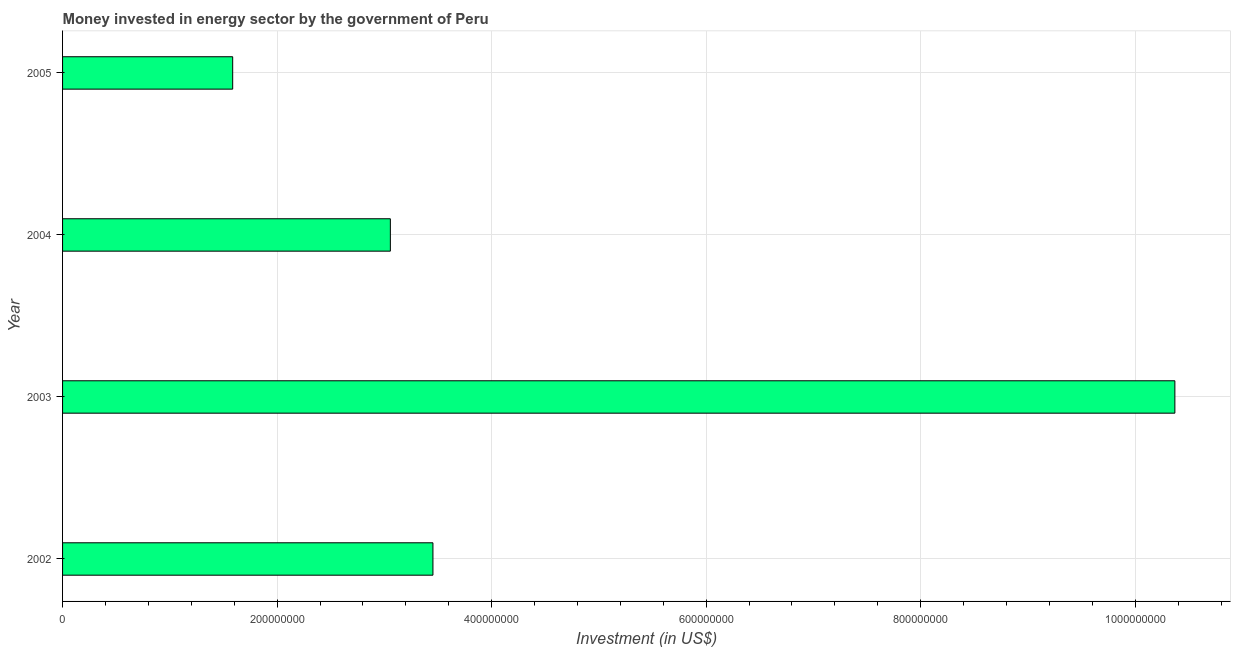What is the title of the graph?
Make the answer very short. Money invested in energy sector by the government of Peru. What is the label or title of the X-axis?
Keep it short and to the point. Investment (in US$). What is the label or title of the Y-axis?
Make the answer very short. Year. What is the investment in energy in 2002?
Your response must be concise. 3.45e+08. Across all years, what is the maximum investment in energy?
Your response must be concise. 1.04e+09. Across all years, what is the minimum investment in energy?
Make the answer very short. 1.59e+08. What is the sum of the investment in energy?
Make the answer very short. 1.85e+09. What is the difference between the investment in energy in 2004 and 2005?
Offer a very short reply. 1.47e+08. What is the average investment in energy per year?
Keep it short and to the point. 4.62e+08. What is the median investment in energy?
Your answer should be very brief. 3.25e+08. In how many years, is the investment in energy greater than 480000000 US$?
Your answer should be compact. 1. Do a majority of the years between 2004 and 2005 (inclusive) have investment in energy greater than 200000000 US$?
Ensure brevity in your answer.  No. What is the ratio of the investment in energy in 2002 to that in 2005?
Offer a terse response. 2.18. Is the investment in energy in 2002 less than that in 2004?
Ensure brevity in your answer.  No. Is the difference between the investment in energy in 2003 and 2004 greater than the difference between any two years?
Keep it short and to the point. No. What is the difference between the highest and the second highest investment in energy?
Give a very brief answer. 6.92e+08. What is the difference between the highest and the lowest investment in energy?
Your answer should be very brief. 8.78e+08. How many bars are there?
Your answer should be compact. 4. How many years are there in the graph?
Your answer should be compact. 4. What is the difference between two consecutive major ticks on the X-axis?
Offer a very short reply. 2.00e+08. What is the Investment (in US$) in 2002?
Keep it short and to the point. 3.45e+08. What is the Investment (in US$) of 2003?
Offer a terse response. 1.04e+09. What is the Investment (in US$) in 2004?
Your answer should be very brief. 3.06e+08. What is the Investment (in US$) of 2005?
Keep it short and to the point. 1.59e+08. What is the difference between the Investment (in US$) in 2002 and 2003?
Ensure brevity in your answer.  -6.92e+08. What is the difference between the Investment (in US$) in 2002 and 2004?
Provide a succinct answer. 3.97e+07. What is the difference between the Investment (in US$) in 2002 and 2005?
Give a very brief answer. 1.87e+08. What is the difference between the Investment (in US$) in 2003 and 2004?
Your answer should be compact. 7.31e+08. What is the difference between the Investment (in US$) in 2003 and 2005?
Your response must be concise. 8.78e+08. What is the difference between the Investment (in US$) in 2004 and 2005?
Your answer should be compact. 1.47e+08. What is the ratio of the Investment (in US$) in 2002 to that in 2003?
Give a very brief answer. 0.33. What is the ratio of the Investment (in US$) in 2002 to that in 2004?
Keep it short and to the point. 1.13. What is the ratio of the Investment (in US$) in 2002 to that in 2005?
Your response must be concise. 2.18. What is the ratio of the Investment (in US$) in 2003 to that in 2004?
Give a very brief answer. 3.39. What is the ratio of the Investment (in US$) in 2003 to that in 2005?
Your answer should be compact. 6.54. What is the ratio of the Investment (in US$) in 2004 to that in 2005?
Provide a short and direct response. 1.93. 